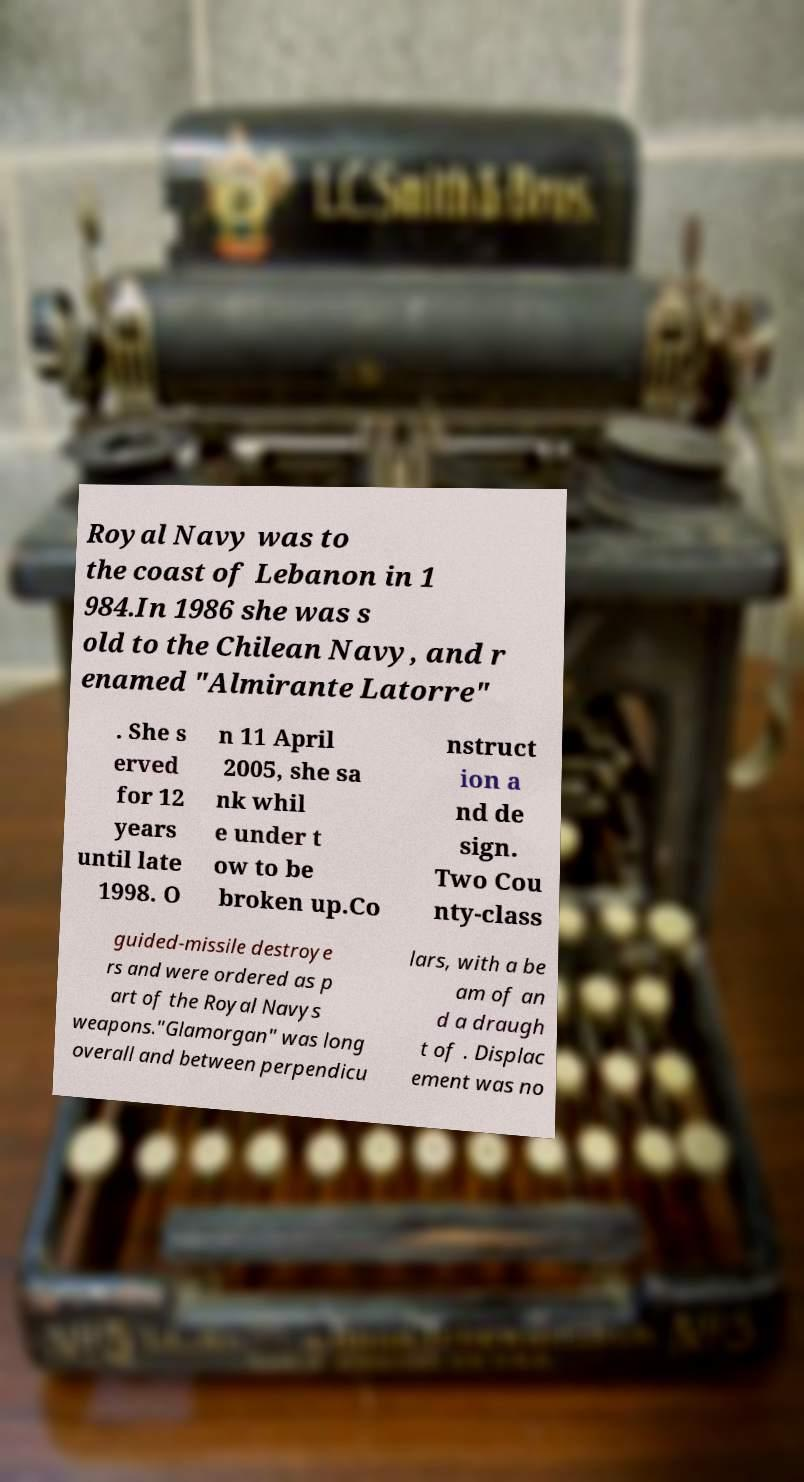Can you read and provide the text displayed in the image?This photo seems to have some interesting text. Can you extract and type it out for me? Royal Navy was to the coast of Lebanon in 1 984.In 1986 she was s old to the Chilean Navy, and r enamed "Almirante Latorre" . She s erved for 12 years until late 1998. O n 11 April 2005, she sa nk whil e under t ow to be broken up.Co nstruct ion a nd de sign. Two Cou nty-class guided-missile destroye rs and were ordered as p art of the Royal Navys weapons."Glamorgan" was long overall and between perpendicu lars, with a be am of an d a draugh t of . Displac ement was no 